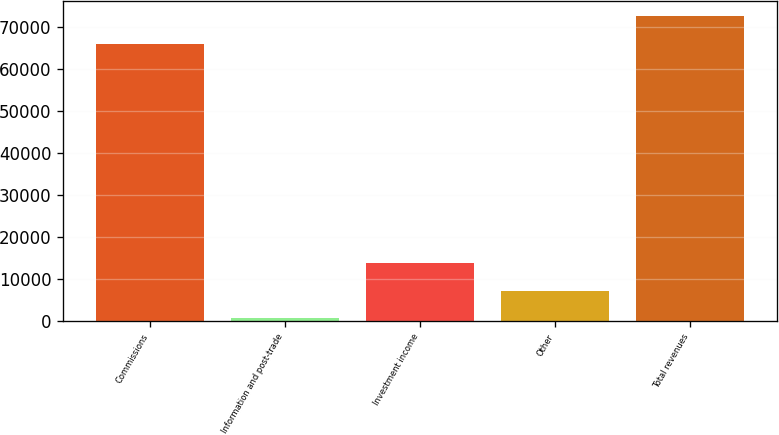Convert chart. <chart><loc_0><loc_0><loc_500><loc_500><bar_chart><fcel>Commissions<fcel>Information and post-trade<fcel>Investment income<fcel>Other<fcel>Total revenues<nl><fcel>66086<fcel>565<fcel>13816.2<fcel>7190.6<fcel>72711.6<nl></chart> 